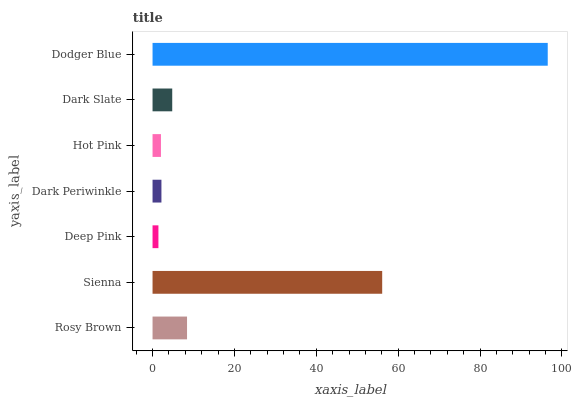Is Deep Pink the minimum?
Answer yes or no. Yes. Is Dodger Blue the maximum?
Answer yes or no. Yes. Is Sienna the minimum?
Answer yes or no. No. Is Sienna the maximum?
Answer yes or no. No. Is Sienna greater than Rosy Brown?
Answer yes or no. Yes. Is Rosy Brown less than Sienna?
Answer yes or no. Yes. Is Rosy Brown greater than Sienna?
Answer yes or no. No. Is Sienna less than Rosy Brown?
Answer yes or no. No. Is Dark Slate the high median?
Answer yes or no. Yes. Is Dark Slate the low median?
Answer yes or no. Yes. Is Dark Periwinkle the high median?
Answer yes or no. No. Is Hot Pink the low median?
Answer yes or no. No. 